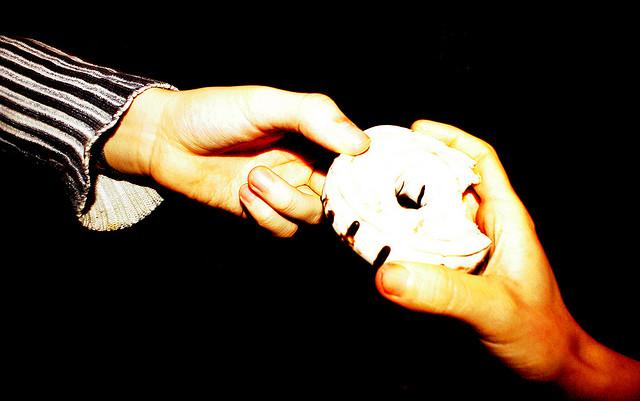What are they exchanging?
Write a very short answer. Donut. Does the man know the person he is handing the item to?
Answer briefly. Yes. Are these people related to each other?
Keep it brief. Yes. 